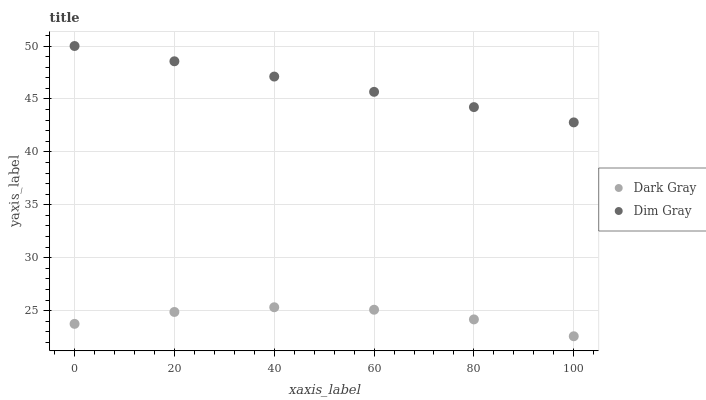Does Dark Gray have the minimum area under the curve?
Answer yes or no. Yes. Does Dim Gray have the maximum area under the curve?
Answer yes or no. Yes. Does Dim Gray have the minimum area under the curve?
Answer yes or no. No. Is Dim Gray the smoothest?
Answer yes or no. Yes. Is Dark Gray the roughest?
Answer yes or no. Yes. Is Dim Gray the roughest?
Answer yes or no. No. Does Dark Gray have the lowest value?
Answer yes or no. Yes. Does Dim Gray have the lowest value?
Answer yes or no. No. Does Dim Gray have the highest value?
Answer yes or no. Yes. Is Dark Gray less than Dim Gray?
Answer yes or no. Yes. Is Dim Gray greater than Dark Gray?
Answer yes or no. Yes. Does Dark Gray intersect Dim Gray?
Answer yes or no. No. 